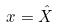<formula> <loc_0><loc_0><loc_500><loc_500>x = \hat { X }</formula> 